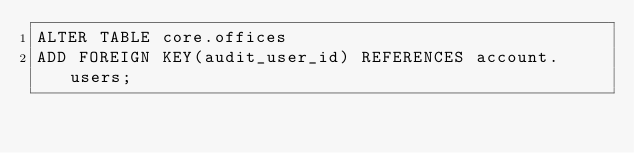<code> <loc_0><loc_0><loc_500><loc_500><_SQL_>ALTER TABLE core.offices
ADD FOREIGN KEY(audit_user_id) REFERENCES account.users;</code> 